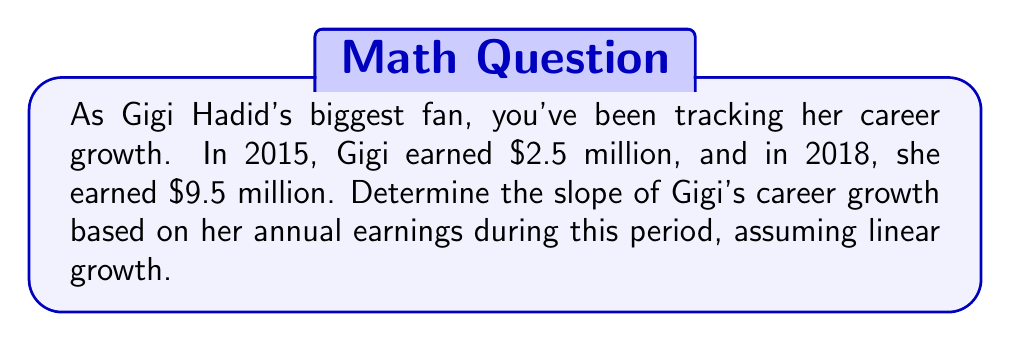Give your solution to this math problem. Let's approach this step-by-step:

1) The slope formula is:
   $$ m = \frac{y_2 - y_1}{x_2 - x_1} $$
   where $(x_1, y_1)$ and $(x_2, y_2)$ are two points on the line.

2) In this case:
   - $x_1 = 2015$, $y_1 = 2.5$ (million dollars)
   - $x_2 = 2018$, $y_2 = 9.5$ (million dollars)

3) Plugging these values into the slope formula:
   $$ m = \frac{9.5 - 2.5}{2018 - 2015} = \frac{7}{3} $$

4) Simplify:
   $$ m = \frac{7}{3} \approx 2.33 $$

5) Interpret the result: Gigi's earnings increased by approximately $2.33 million per year from 2015 to 2018.
Answer: $\frac{7}{3}$ million dollars per year 